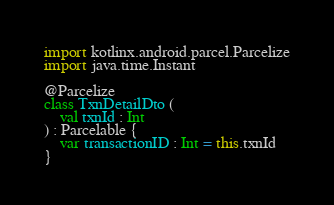Convert code to text. <code><loc_0><loc_0><loc_500><loc_500><_Kotlin_>import kotlinx.android.parcel.Parcelize
import java.time.Instant

@Parcelize
class TxnDetailDto (
    val txnId : Int
) : Parcelable {
    var transactionID : Int = this.txnId
}</code> 